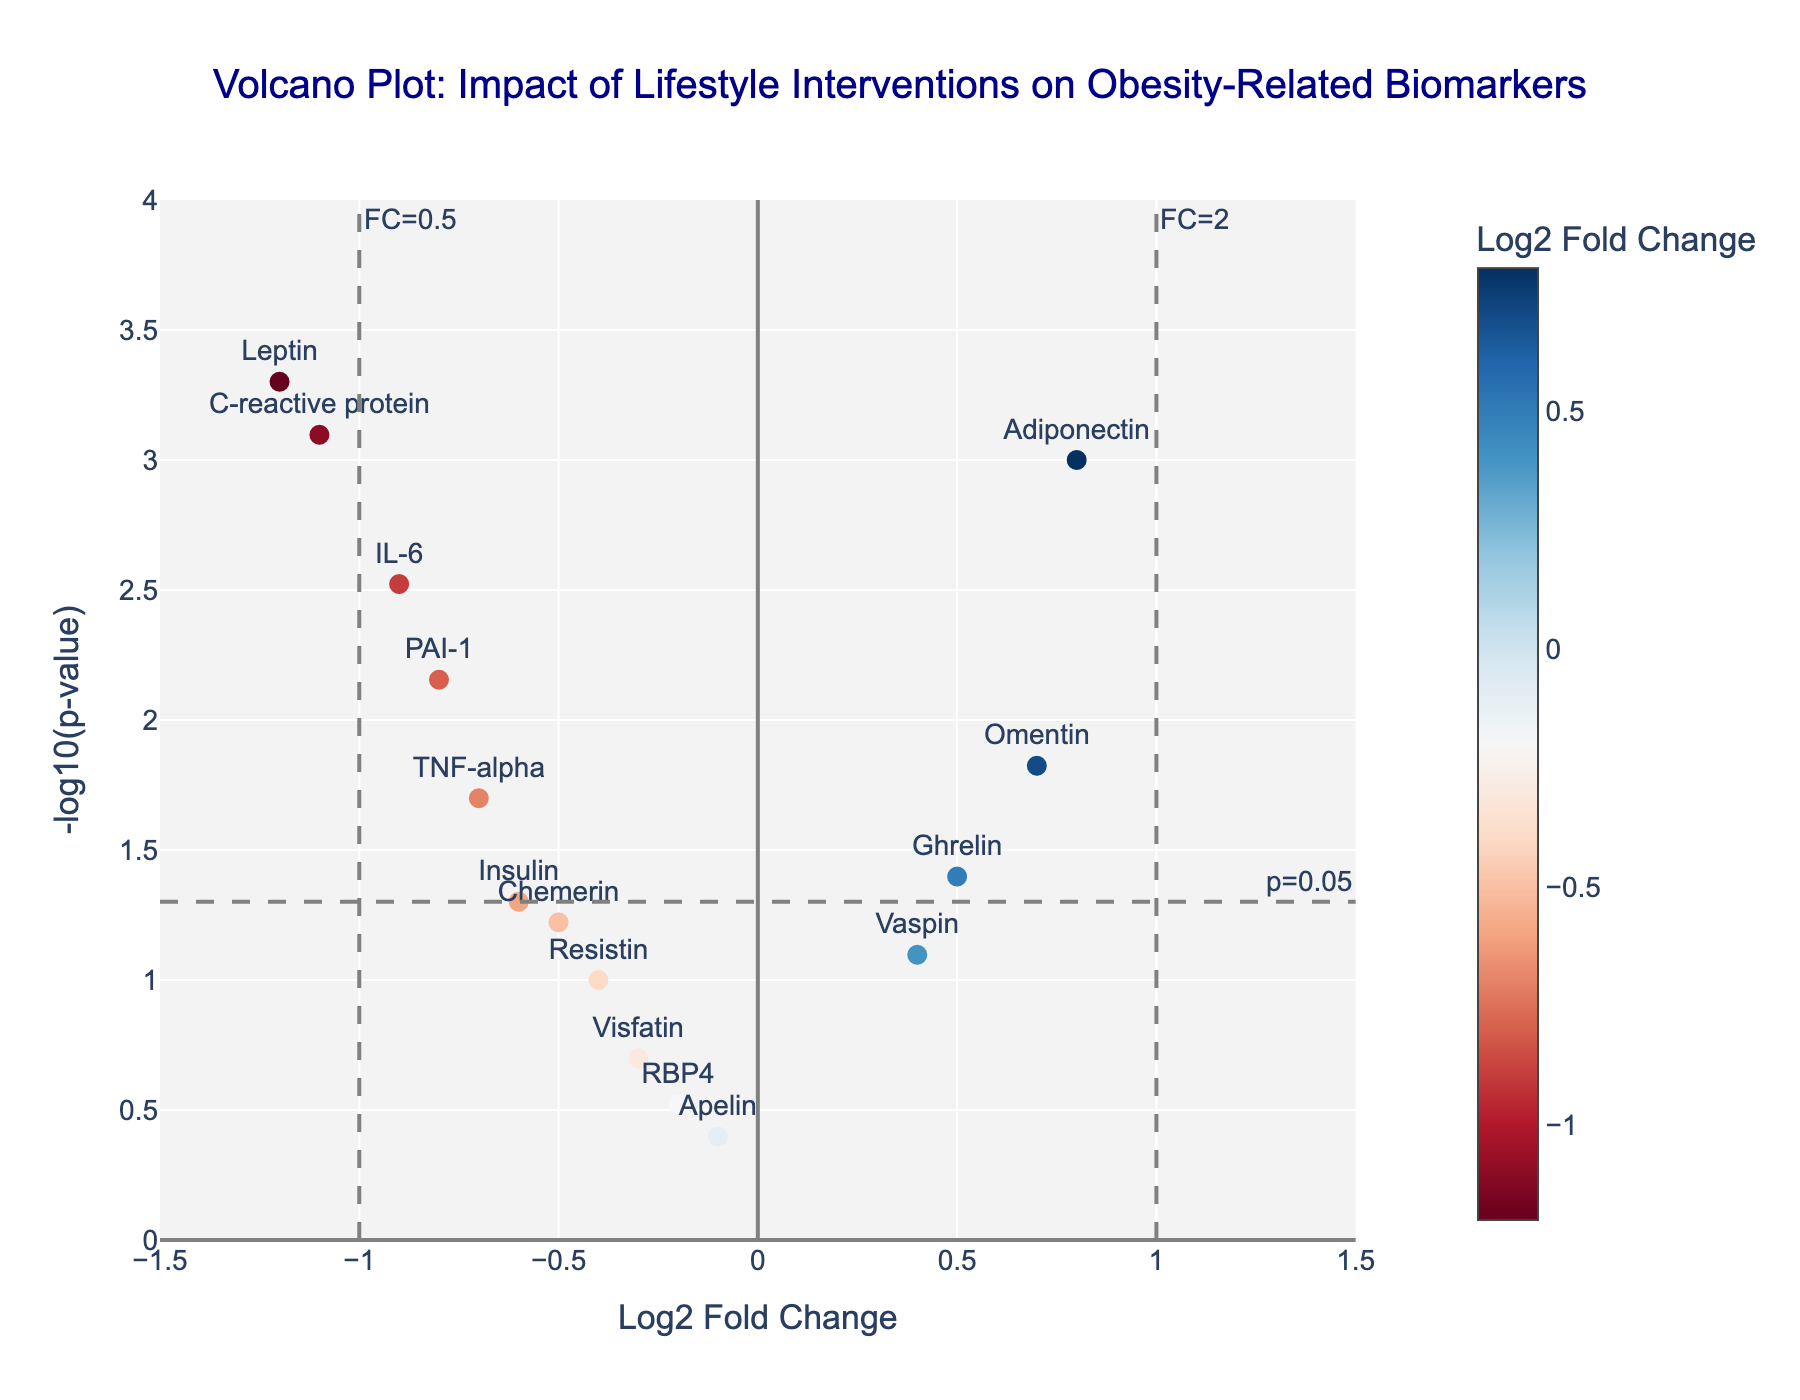How many biomarkers have a p-value less than 0.05? There is a horizontal line at -log10(0.05) to mark significant p-values. Biomarkers above this line have p-values less than 0.05. Count the markers above this line.
Answer: 9 Which biomarker has the highest log2 fold change? Look for the marker with the highest value on the x-axis (Log2 Fold Change).
Answer: Leptin What is the log2 fold change and p-value of the Adiponectin marker? Hover over the Adiponectin point in the plot to get detailed information.
Answer: Log2FC: 0.80, p-value: 0.001 How many biomarkers have a negative log2 fold change but are not statistically significant? Look for the biomarkers on the left side of zero (negative fold change) and below the -log10(0.05) horizontal line.
Answer: 3 (Insulin, Chemerin, Resistin) Which biomarker is the most statistically significant? The significance is determined by the marker with the highest -log10(p-value). Look for the marker at the highest point on the y-axis.
Answer: Leptin What is the range of the y-axis on the plot? Look at the y-axis labels to determine the range.
Answer: 0 to 4 How many biomarkers have a positive log2 fold change? Count all the biomarkers to the right of the zero line on the x-axis (Log2 Fold Change).
Answer: 5 Which biomarkers fall within the log2 fold change cutoffs of -1 and 1 and are statistically significant? Identify the markers between -1 and 1 on the x-axis and above the -log10(0.05) horizontal line.
Answer: Adiponectin, IL-6, TNF-alpha, C-reactive protein, PAI-1, Omentin What’s the log2 fold change for the biomarker Ghrelin? Hover over the Ghrelin point or read the label on the x-axis.
Answer: 0.5 Which biomarkers have log2 fold changes between -0.5 and 0.5 and p-values greater than 0.05? Look for markers between -0.5 and 0.5 on the x-axis and below the -log10(0.05) horizontal line.
Answer: Resistin, Visfatin, Chemerin, RBP4, Vaspin, Apelin 